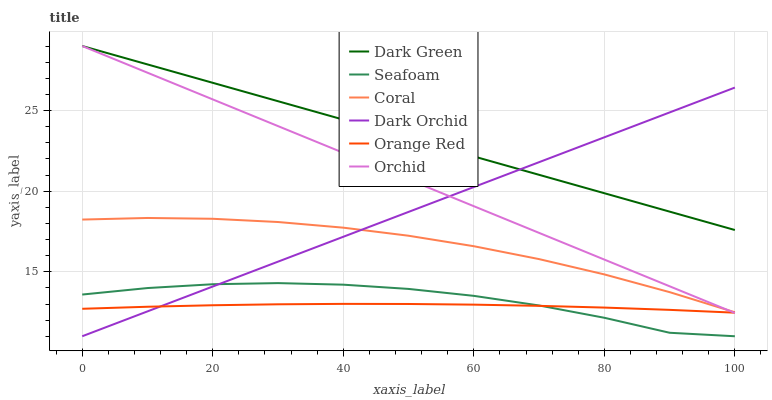Does Orange Red have the minimum area under the curve?
Answer yes or no. Yes. Does Dark Green have the maximum area under the curve?
Answer yes or no. Yes. Does Seafoam have the minimum area under the curve?
Answer yes or no. No. Does Seafoam have the maximum area under the curve?
Answer yes or no. No. Is Dark Green the smoothest?
Answer yes or no. Yes. Is Seafoam the roughest?
Answer yes or no. Yes. Is Dark Orchid the smoothest?
Answer yes or no. No. Is Dark Orchid the roughest?
Answer yes or no. No. Does Seafoam have the lowest value?
Answer yes or no. Yes. Does Dark Green have the lowest value?
Answer yes or no. No. Does Orchid have the highest value?
Answer yes or no. Yes. Does Seafoam have the highest value?
Answer yes or no. No. Is Coral less than Dark Green?
Answer yes or no. Yes. Is Coral greater than Orange Red?
Answer yes or no. Yes. Does Orange Red intersect Dark Orchid?
Answer yes or no. Yes. Is Orange Red less than Dark Orchid?
Answer yes or no. No. Is Orange Red greater than Dark Orchid?
Answer yes or no. No. Does Coral intersect Dark Green?
Answer yes or no. No. 